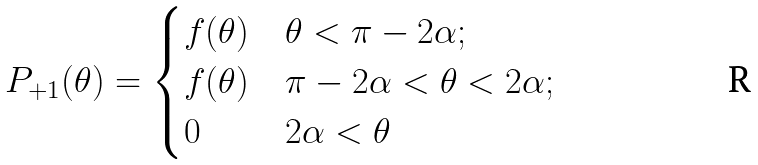<formula> <loc_0><loc_0><loc_500><loc_500>P _ { + 1 } ( \theta ) = \begin{cases} f ( \theta ) & \theta < \pi - 2 \alpha ; \\ f ( \theta ) & \pi - 2 \alpha < \theta < 2 \alpha ; \\ 0 & 2 \alpha < \theta \\ \end{cases}</formula> 